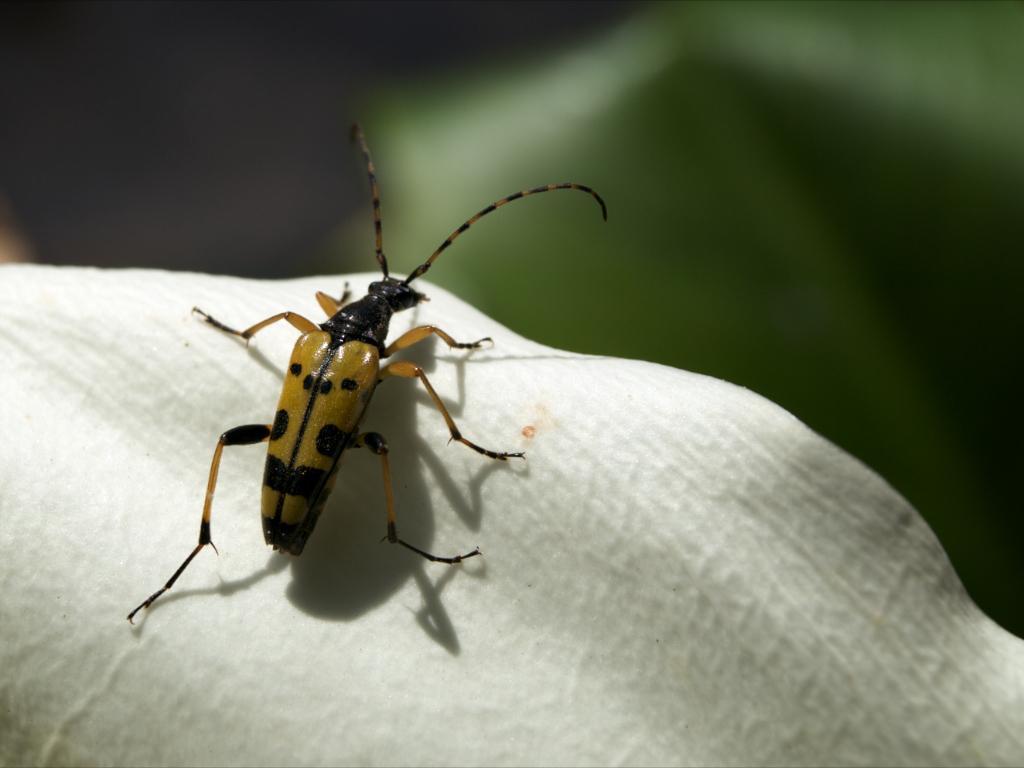Could you give a brief overview of what you see in this image? This image consists of an insect. At the bottom, it looks like a flower petal in white color. The background is blurred. 